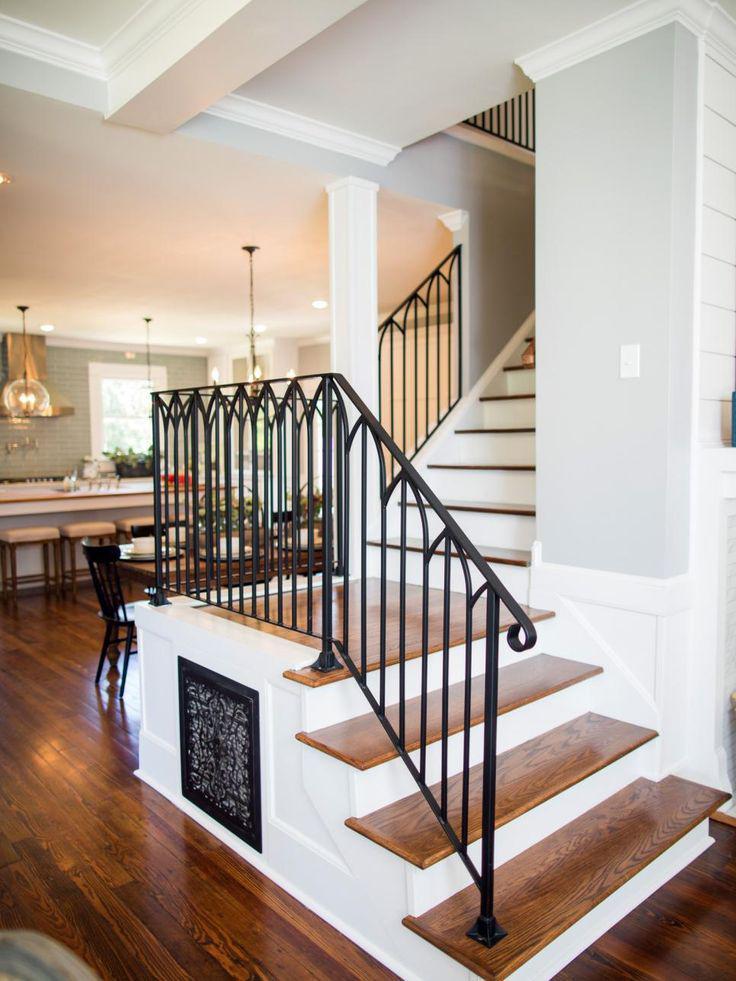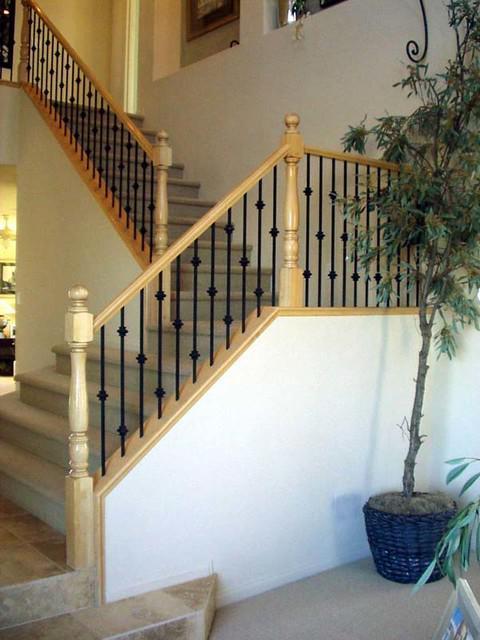The first image is the image on the left, the second image is the image on the right. Examine the images to the left and right. Is the description "There is one set of stairs that has no risers." accurate? Answer yes or no. No. 